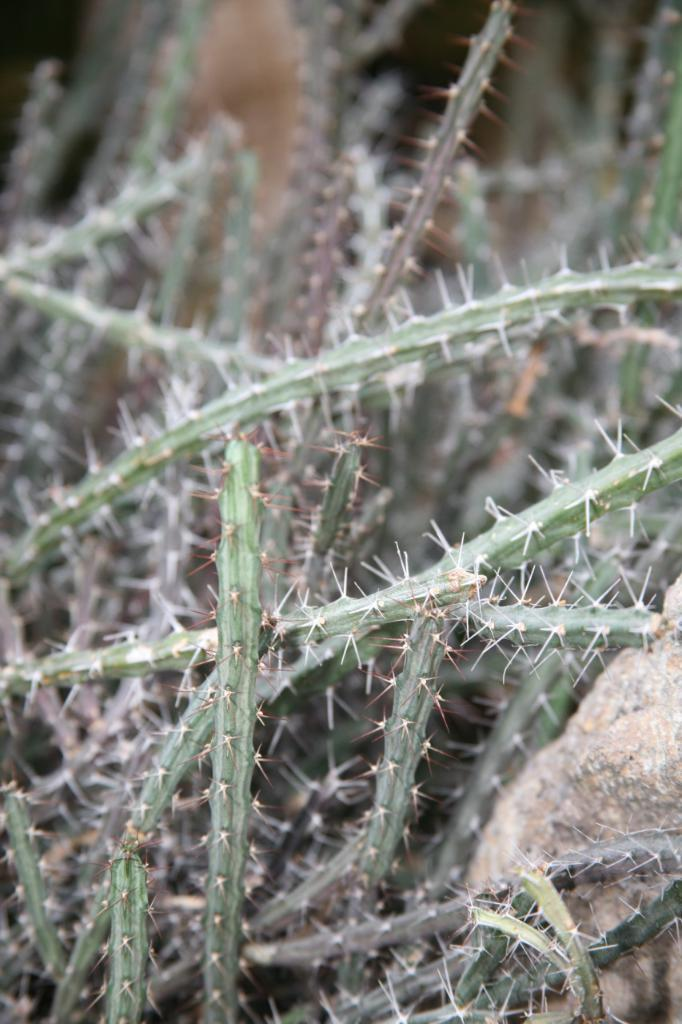What type of plants are present in the image? There are cactus plants with thorns in the image. Can you describe the appearance of the plants? The cactus plants have thorns. What is located behind a plant on the right side of the image? There is a stone behind a plant on the right side of the image. What type of dress is the bird wearing in the image? There is no bird present in the image, and therefore no dress or bird can be observed. 